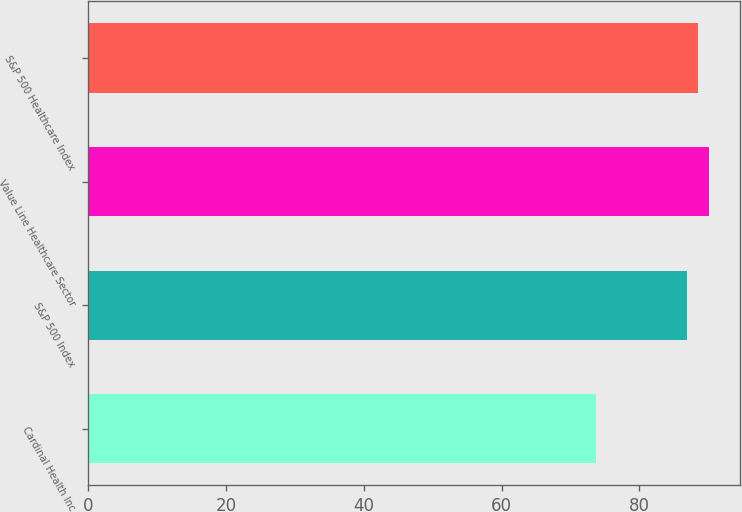Convert chart. <chart><loc_0><loc_0><loc_500><loc_500><bar_chart><fcel>Cardinal Health Inc<fcel>S&P 500 Index<fcel>Value Line Healthcare Sector<fcel>S&P 500 Healthcare Index<nl><fcel>73.68<fcel>86.88<fcel>90.12<fcel>88.5<nl></chart> 